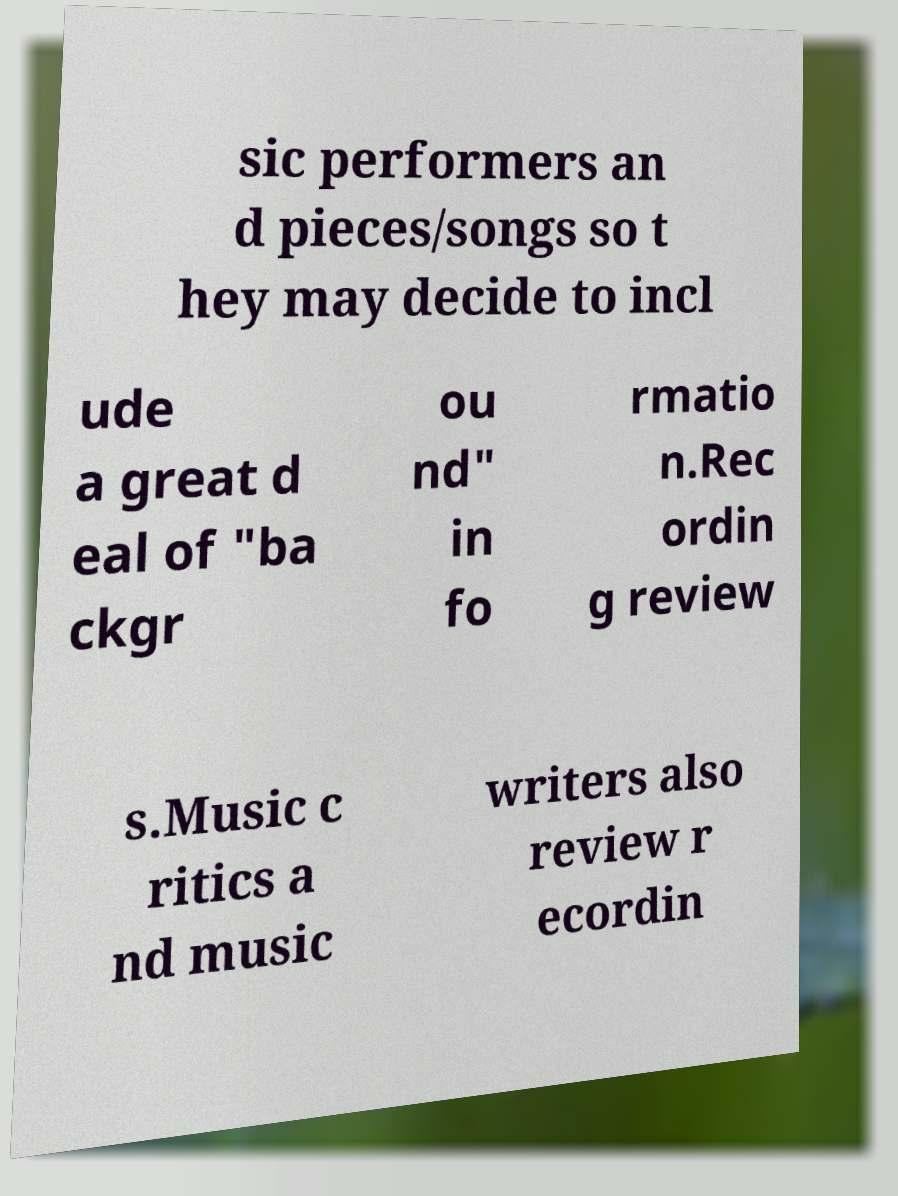Please identify and transcribe the text found in this image. sic performers an d pieces/songs so t hey may decide to incl ude a great d eal of "ba ckgr ou nd" in fo rmatio n.Rec ordin g review s.Music c ritics a nd music writers also review r ecordin 